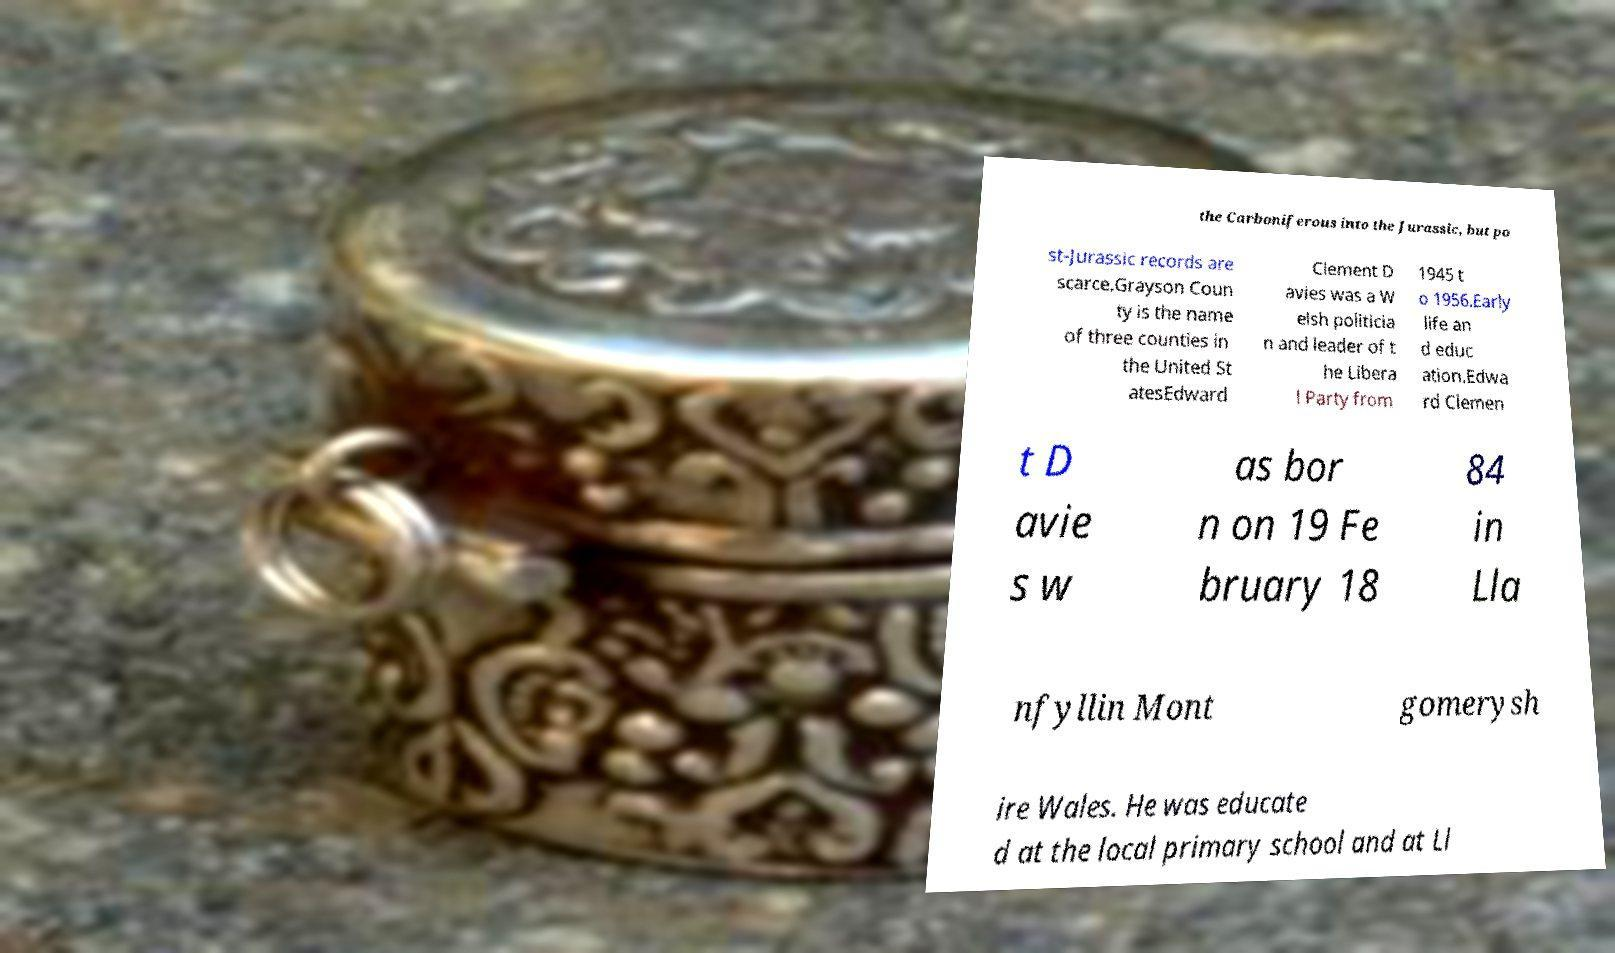There's text embedded in this image that I need extracted. Can you transcribe it verbatim? the Carboniferous into the Jurassic, but po st-Jurassic records are scarce.Grayson Coun ty is the name of three counties in the United St atesEdward Clement D avies was a W elsh politicia n and leader of t he Libera l Party from 1945 t o 1956.Early life an d educ ation.Edwa rd Clemen t D avie s w as bor n on 19 Fe bruary 18 84 in Lla nfyllin Mont gomerysh ire Wales. He was educate d at the local primary school and at Ll 